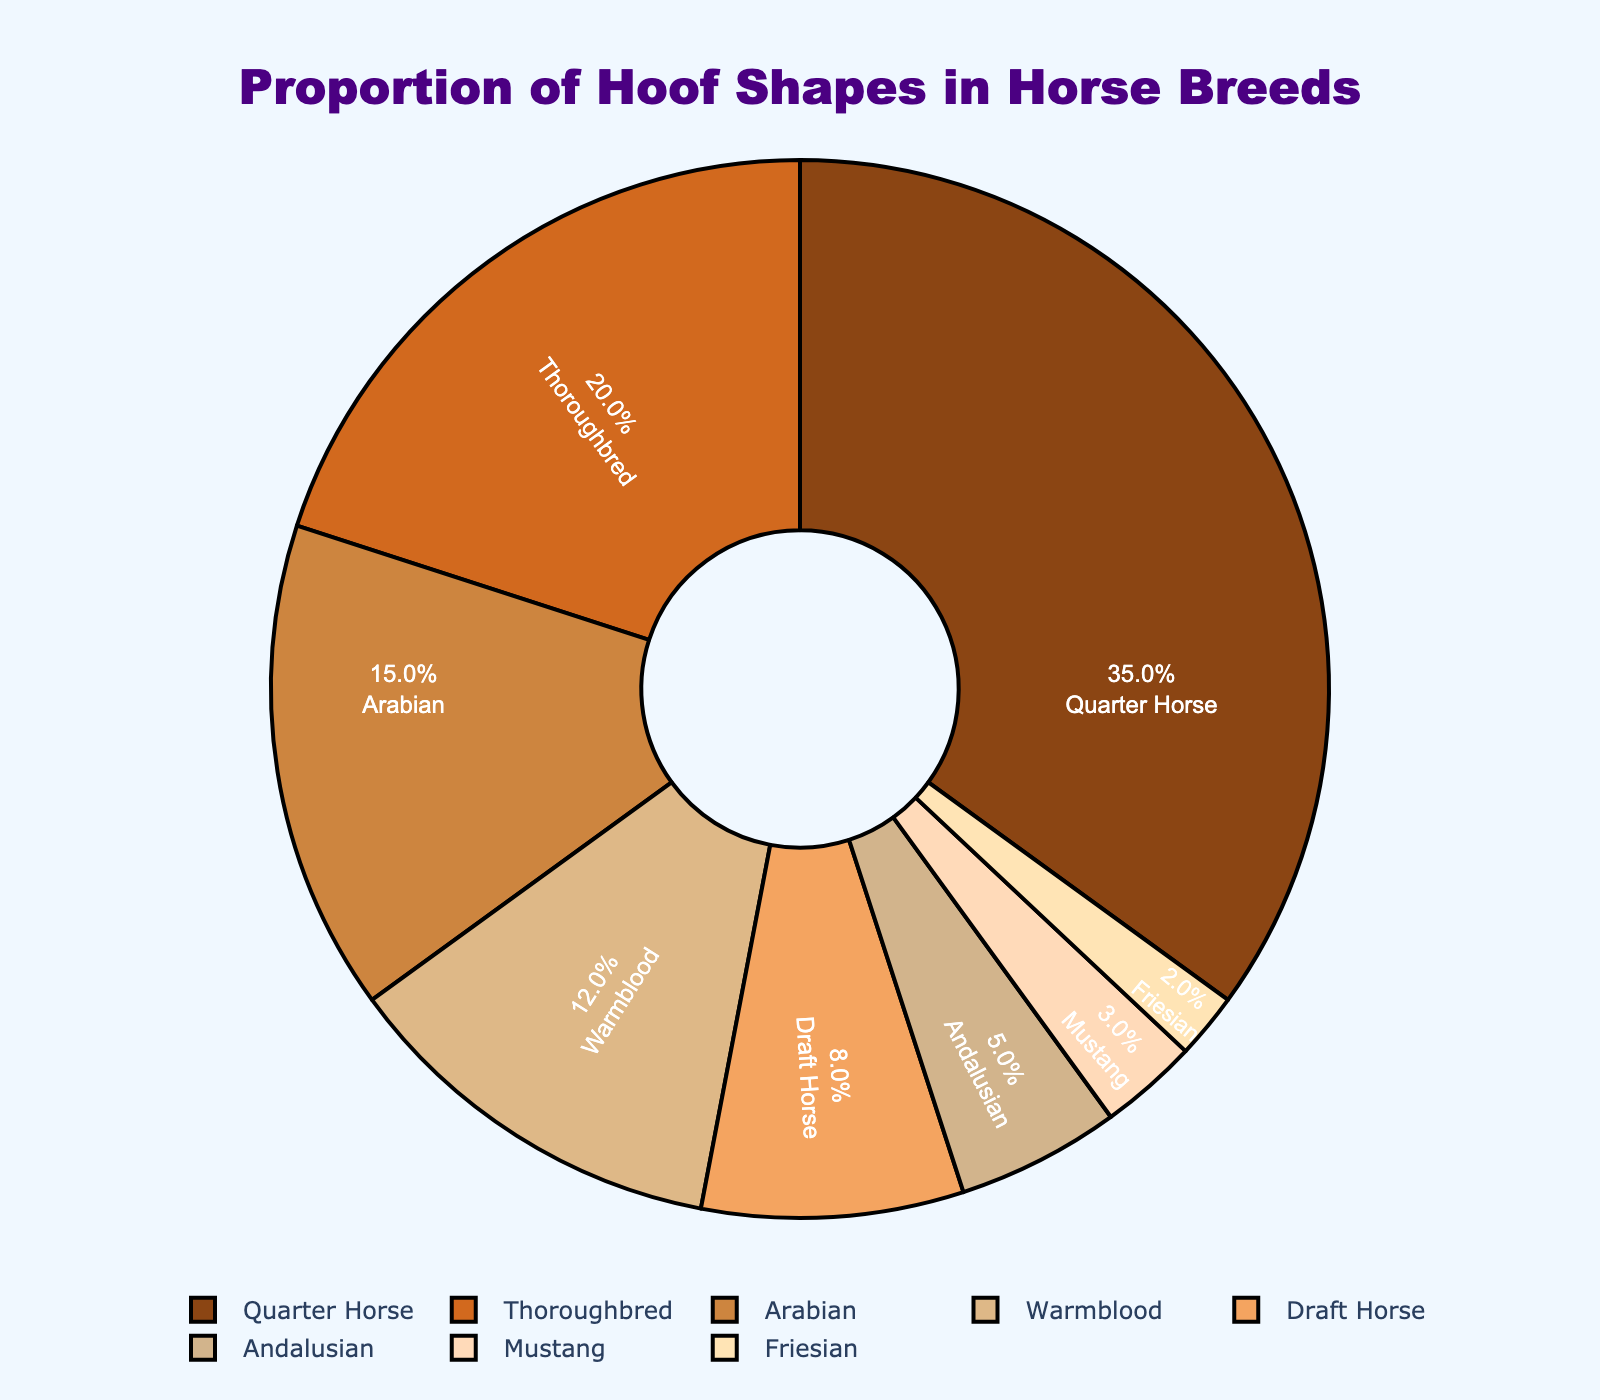Which breed has the largest proportion of hoof shapes? By referring to the pie chart, we can see that the breed with the largest proportion is labeled, which is Quarter Horse with 35%.
Answer: Quarter Horse Which breed has a smaller proportion, Mustang or Friesian? By comparing the sections of the pie chart, the Mustang section is larger than the Friesian section. Therefore, Friesian has a smaller proportion with 2%.
Answer: Friesian What is the combined percentage of hoof shapes found in Draft Horse and Andalusian? By summing the percentages for Draft Horse (8%) and Andalusian (5%), we get 8% + 5% = 13%.
Answer: 13% How much larger is the proportion of hoof shapes found in Quarter Horse compared to Warmblood? The percentage of Quarter Horse is 35% and Warmblood is 12%, so the difference is 35% - 12% = 23%.
Answer: 23% What percentage of hoof shapes is found in breeds with proportions less than 10%? Summing the percentages of Draft Horse (8%), Andalusian (5%), Mustang (3%), and Friesian (2%), we get 8% + 5% + 3% + 2% = 18%.
Answer: 18% Which two breeds together cover the highest proportion of hoof shapes? By checking the pie chart sections, the two largest proportions are for Quarter Horse (35%) and Thoroughbred (20%). Their combined percentage is 35% + 20% = 55%.
Answer: Quarter Horse and Thoroughbred Is the proportion of hoof shapes in Warmblood greater than that in Arabian? Comparing the percentages, Warmblood has 12% and Arabian has 15%. 12% is not greater than 15%.
Answer: No Which breed has the smallest proportion of hoof shapes? By looking at the smallest section in the pie chart, it is Friesian with 2%.
Answer: Friesian 